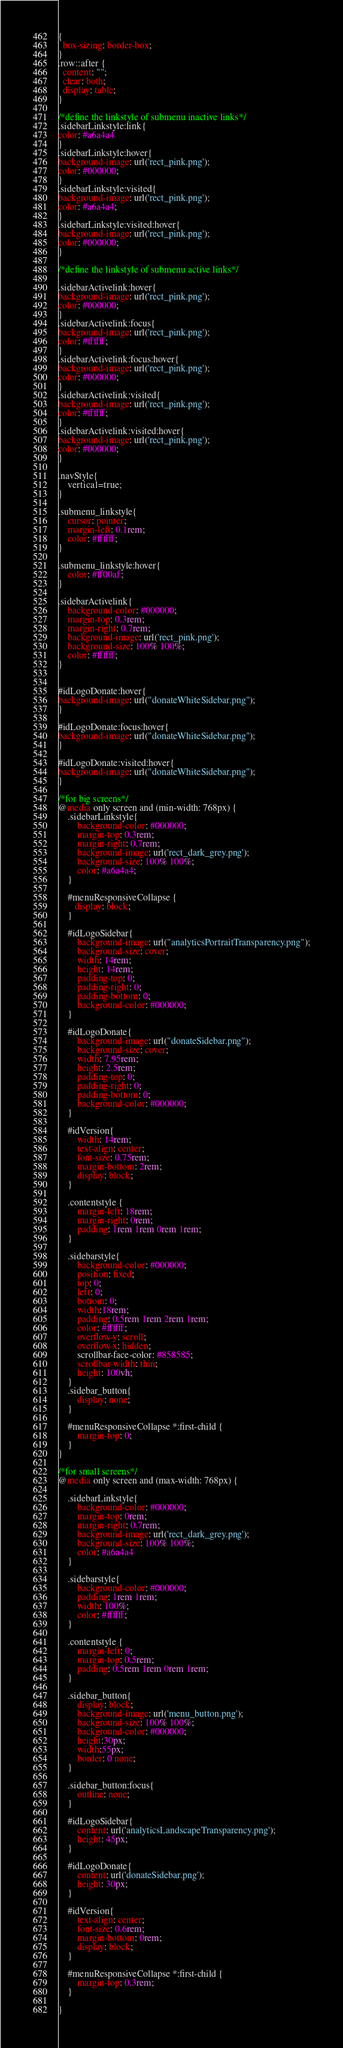Convert code to text. <code><loc_0><loc_0><loc_500><loc_500><_CSS_>
{
  box-sizing: border-box;
}
.row::after {
  content: "";
  clear: both;
  display: table;
}

/*define the linkstyle of submenu inactive links*/
.sidebarLinkstyle:link{
color: #a6a4a4
}
.sidebarLinkstyle:hover{
background-image: url('rect_pink.png');
color: #000000;
}
.sidebarLinkstyle:visited{
background-image: url('rect_pink.png');
color: #a6a4a4;
}
.sidebarLinkstyle:visited:hover{
background-image: url('rect_pink.png');
color: #000000;
}

/*define the linkstyle of submenu active links*/

.sidebarActivelink:hover{
background-image: url('rect_pink.png');
color: #000000;
}
.sidebarActivelink:focus{
background-image: url('rect_pink.png');
color: #ffffff;
}
.sidebarActivelink:focus:hover{
background-image: url('rect_pink.png');
color: #000000;
}
.sidebarActivelink:visited{
background-image: url('rect_pink.png');
color: #ffffff;
}
.sidebarActivelink:visited:hover{
background-image: url('rect_pink.png');
color: #000000;
}

.navStyle{
    vertical=true;
}

.submenu_linkstyle{
    cursor: pointer;
    margin-left: 0.1rem;
    color: #ffffff;
}

.submenu_linkstyle:hover{
    color: #ff00af;
}

.sidebarActivelink{
    background-color: #000000;
    margin-top: 0.3rem;
    margin-right: 0.7rem;
    background-image: url('rect_pink.png');
    background-size: 100% 100%;
    color: #ffffff;
}


#idLogoDonate:hover{
background-image: url("donateWhiteSidebar.png");
}

#idLogoDonate:focus:hover{
background-image: url("donateWhiteSidebar.png");
}

#idLogoDonate:visited:hover{
background-image: url("donateWhiteSidebar.png");
}

/*for big screens*/
@media only screen and (min-width: 768px) {
    .sidebarLinkstyle{
        background-color: #000000;
        margin-top: 0.3rem;
        margin-right: 0.7rem;
        background-image: url('rect_dark_grey.png');
        background-size: 100% 100%;
        color: #a6a4a4;
    }

    #menuResponsiveCollapse {
       display: block;
    }

    #idLogoSidebar{
        background-image: url("analyticsPortraitTransparency.png");
        background-size: cover;
        width: 14rem;
        height: 14rem;
        padding-top: 0;
        padding-right: 0;
        padding-bottom: 0;
        background-color: #000000;
    }

    #idLogoDonate{
        background-image: url("donateSidebar.png");
        background-size: cover;
        width: 7.95rem;
        height: 2.5rem;
        padding-top: 0;
        padding-right: 0;
        padding-bottom: 0;
        background-color: #000000;
    }

    #idVersion{
        width: 14rem;
        text-align: center;
        font-size: 0.75rem;
        margin-bottom: 2rem;
        display: block;
    }

    .contentstyle {
        margin-left: 18rem;
        margin-right: 0rem;
        padding: 1rem 1rem 0rem 1rem;
    }

    .sidebarstyle{
        background-color: #000000;
        position: fixed;
        top: 0;
        left: 0;
        bottom: 0;
        width:18rem;
        padding: 0.5rem 1rem 2rem 1rem;
        color: #ffffff;
        overflow-y: scroll;
        overflow-x: hidden;
        scrollbar-face-color: #858585;
        scrollbar-width: thin;
        height: 100vh;
    }
    .sidebar_button{
        display: none;
    }

    #menuResponsiveCollapse *:first-child {
        margin-top: 0;
    }
}

/*for small screens*/
@media only screen and (max-width: 768px) {

    .sidebarLinkstyle{
        background-color: #000000;
        margin-top: 0rem;
        margin-right: 0.7rem;
        background-image: url('rect_dark_grey.png');
        background-size: 100% 100%;
        color: #a6a4a4
    }

    .sidebarstyle{
        background-color: #000000;
        padding: 1rem 1rem;
        width: 100%;
        color: #ffffff;
    }

    .contentstyle {
        margin-left: 0;
        margin-top: 0.5rem;
        padding: 0.5rem 1rem 0rem 1rem;
    }

    .sidebar_button{
        display: block;
        background-image: url('menu_button.png');
        background-size: 100% 100%;
        background-color: #000000;
        height:30px;
        width:55px;
        border: 0 none;
    }

    .sidebar_button:focus{
        outline: none;
    }

    #idLogoSidebar{
        content: url('analyticsLandscapeTransparency.png');
        height: 45px;
    }

    #idLogoDonate{
        content: url('donateSidebar.png');
        height: 30px;
    }

    #idVersion{
        text-align: center;
        font-size: 0.6rem;
        margin-bottom: 0rem;
        display: block;
    }

    #menuResponsiveCollapse *:first-child {
        margin-top: 0.3rem;
    }

}</code> 